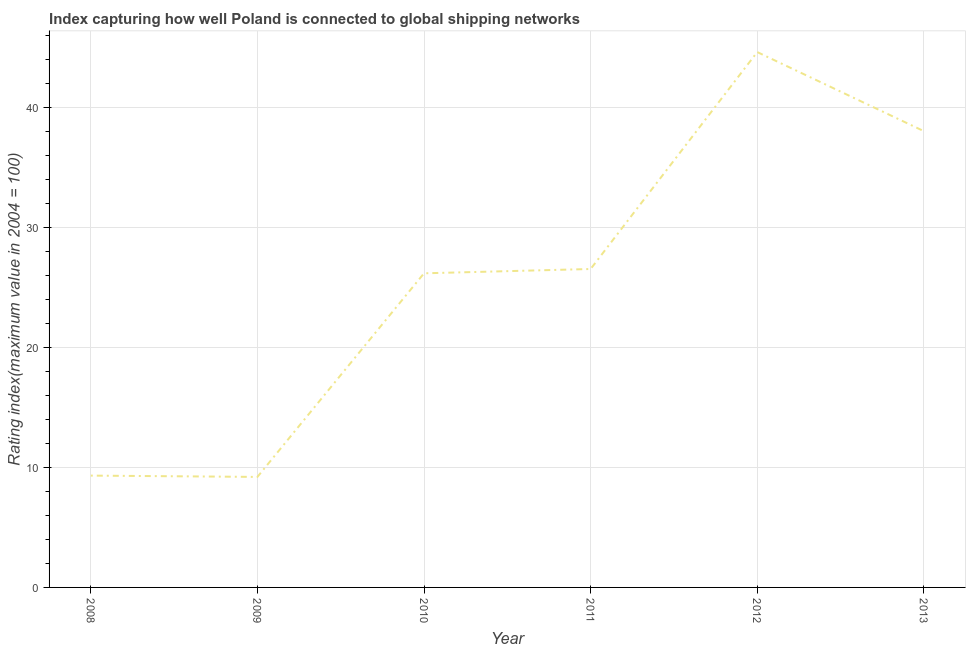What is the liner shipping connectivity index in 2008?
Offer a very short reply. 9.32. Across all years, what is the maximum liner shipping connectivity index?
Your answer should be compact. 44.62. Across all years, what is the minimum liner shipping connectivity index?
Provide a succinct answer. 9.21. In which year was the liner shipping connectivity index maximum?
Make the answer very short. 2012. What is the sum of the liner shipping connectivity index?
Provide a succinct answer. 153.9. What is the difference between the liner shipping connectivity index in 2008 and 2010?
Offer a terse response. -16.86. What is the average liner shipping connectivity index per year?
Ensure brevity in your answer.  25.65. What is the median liner shipping connectivity index?
Your response must be concise. 26.36. In how many years, is the liner shipping connectivity index greater than 22 ?
Ensure brevity in your answer.  4. What is the ratio of the liner shipping connectivity index in 2010 to that in 2013?
Provide a succinct answer. 0.69. Is the difference between the liner shipping connectivity index in 2011 and 2012 greater than the difference between any two years?
Keep it short and to the point. No. What is the difference between the highest and the second highest liner shipping connectivity index?
Your answer should be very brief. 6.59. Is the sum of the liner shipping connectivity index in 2010 and 2012 greater than the maximum liner shipping connectivity index across all years?
Ensure brevity in your answer.  Yes. What is the difference between the highest and the lowest liner shipping connectivity index?
Ensure brevity in your answer.  35.41. Does the liner shipping connectivity index monotonically increase over the years?
Provide a succinct answer. No. How many years are there in the graph?
Give a very brief answer. 6. What is the difference between two consecutive major ticks on the Y-axis?
Provide a short and direct response. 10. Are the values on the major ticks of Y-axis written in scientific E-notation?
Provide a succinct answer. No. What is the title of the graph?
Your answer should be very brief. Index capturing how well Poland is connected to global shipping networks. What is the label or title of the Y-axis?
Give a very brief answer. Rating index(maximum value in 2004 = 100). What is the Rating index(maximum value in 2004 = 100) in 2008?
Offer a very short reply. 9.32. What is the Rating index(maximum value in 2004 = 100) of 2009?
Keep it short and to the point. 9.21. What is the Rating index(maximum value in 2004 = 100) of 2010?
Ensure brevity in your answer.  26.18. What is the Rating index(maximum value in 2004 = 100) in 2011?
Your answer should be very brief. 26.54. What is the Rating index(maximum value in 2004 = 100) of 2012?
Keep it short and to the point. 44.62. What is the Rating index(maximum value in 2004 = 100) of 2013?
Your answer should be compact. 38.03. What is the difference between the Rating index(maximum value in 2004 = 100) in 2008 and 2009?
Make the answer very short. 0.11. What is the difference between the Rating index(maximum value in 2004 = 100) in 2008 and 2010?
Your answer should be very brief. -16.86. What is the difference between the Rating index(maximum value in 2004 = 100) in 2008 and 2011?
Offer a very short reply. -17.22. What is the difference between the Rating index(maximum value in 2004 = 100) in 2008 and 2012?
Provide a short and direct response. -35.3. What is the difference between the Rating index(maximum value in 2004 = 100) in 2008 and 2013?
Your answer should be compact. -28.71. What is the difference between the Rating index(maximum value in 2004 = 100) in 2009 and 2010?
Give a very brief answer. -16.97. What is the difference between the Rating index(maximum value in 2004 = 100) in 2009 and 2011?
Provide a short and direct response. -17.33. What is the difference between the Rating index(maximum value in 2004 = 100) in 2009 and 2012?
Offer a very short reply. -35.41. What is the difference between the Rating index(maximum value in 2004 = 100) in 2009 and 2013?
Provide a short and direct response. -28.82. What is the difference between the Rating index(maximum value in 2004 = 100) in 2010 and 2011?
Provide a succinct answer. -0.36. What is the difference between the Rating index(maximum value in 2004 = 100) in 2010 and 2012?
Offer a very short reply. -18.44. What is the difference between the Rating index(maximum value in 2004 = 100) in 2010 and 2013?
Give a very brief answer. -11.85. What is the difference between the Rating index(maximum value in 2004 = 100) in 2011 and 2012?
Give a very brief answer. -18.08. What is the difference between the Rating index(maximum value in 2004 = 100) in 2011 and 2013?
Provide a short and direct response. -11.49. What is the difference between the Rating index(maximum value in 2004 = 100) in 2012 and 2013?
Make the answer very short. 6.59. What is the ratio of the Rating index(maximum value in 2004 = 100) in 2008 to that in 2009?
Ensure brevity in your answer.  1.01. What is the ratio of the Rating index(maximum value in 2004 = 100) in 2008 to that in 2010?
Provide a succinct answer. 0.36. What is the ratio of the Rating index(maximum value in 2004 = 100) in 2008 to that in 2011?
Offer a very short reply. 0.35. What is the ratio of the Rating index(maximum value in 2004 = 100) in 2008 to that in 2012?
Offer a terse response. 0.21. What is the ratio of the Rating index(maximum value in 2004 = 100) in 2008 to that in 2013?
Your response must be concise. 0.24. What is the ratio of the Rating index(maximum value in 2004 = 100) in 2009 to that in 2010?
Give a very brief answer. 0.35. What is the ratio of the Rating index(maximum value in 2004 = 100) in 2009 to that in 2011?
Ensure brevity in your answer.  0.35. What is the ratio of the Rating index(maximum value in 2004 = 100) in 2009 to that in 2012?
Offer a very short reply. 0.21. What is the ratio of the Rating index(maximum value in 2004 = 100) in 2009 to that in 2013?
Keep it short and to the point. 0.24. What is the ratio of the Rating index(maximum value in 2004 = 100) in 2010 to that in 2011?
Provide a succinct answer. 0.99. What is the ratio of the Rating index(maximum value in 2004 = 100) in 2010 to that in 2012?
Offer a very short reply. 0.59. What is the ratio of the Rating index(maximum value in 2004 = 100) in 2010 to that in 2013?
Give a very brief answer. 0.69. What is the ratio of the Rating index(maximum value in 2004 = 100) in 2011 to that in 2012?
Your answer should be compact. 0.59. What is the ratio of the Rating index(maximum value in 2004 = 100) in 2011 to that in 2013?
Provide a succinct answer. 0.7. What is the ratio of the Rating index(maximum value in 2004 = 100) in 2012 to that in 2013?
Provide a succinct answer. 1.17. 